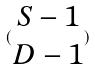Convert formula to latex. <formula><loc_0><loc_0><loc_500><loc_500>( \begin{matrix} S - 1 \\ D - 1 \end{matrix} )</formula> 